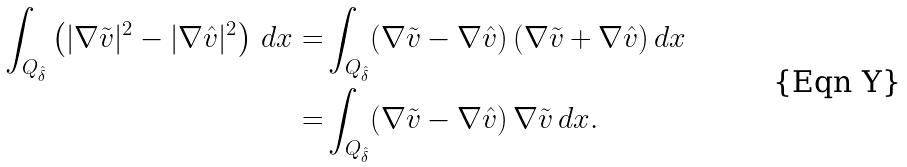<formula> <loc_0><loc_0><loc_500><loc_500>\int _ { Q _ { \hat { \delta } } } \left ( | \nabla \tilde { v } | ^ { 2 } - | \nabla \hat { v } | ^ { 2 } \right ) \, d x = & \int _ { Q _ { \hat { \delta } } } ( \nabla \tilde { v } - \nabla \hat { v } ) \, ( \nabla \tilde { v } + \nabla \hat { v } ) \, d x \\ = & \int _ { Q _ { \hat { \delta } } } ( \nabla \tilde { v } - \nabla \hat { v } ) \, \nabla \tilde { v } \, d x .</formula> 